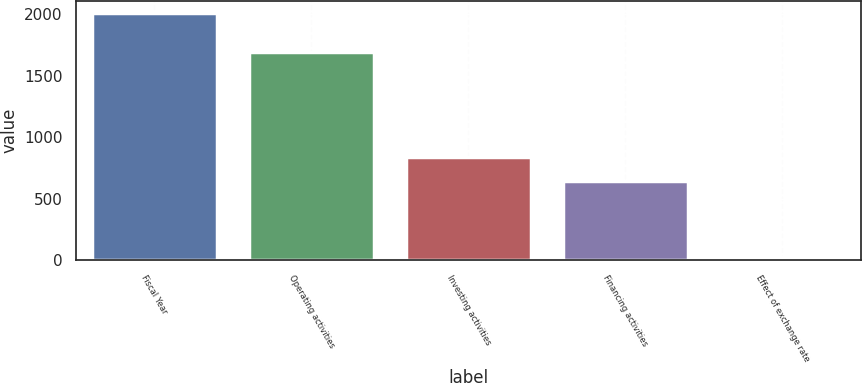Convert chart to OTSL. <chart><loc_0><loc_0><loc_500><loc_500><bar_chart><fcel>Fiscal Year<fcel>Operating activities<fcel>Investing activities<fcel>Financing activities<fcel>Effect of exchange rate<nl><fcel>2006<fcel>1695<fcel>838.9<fcel>641<fcel>27<nl></chart> 